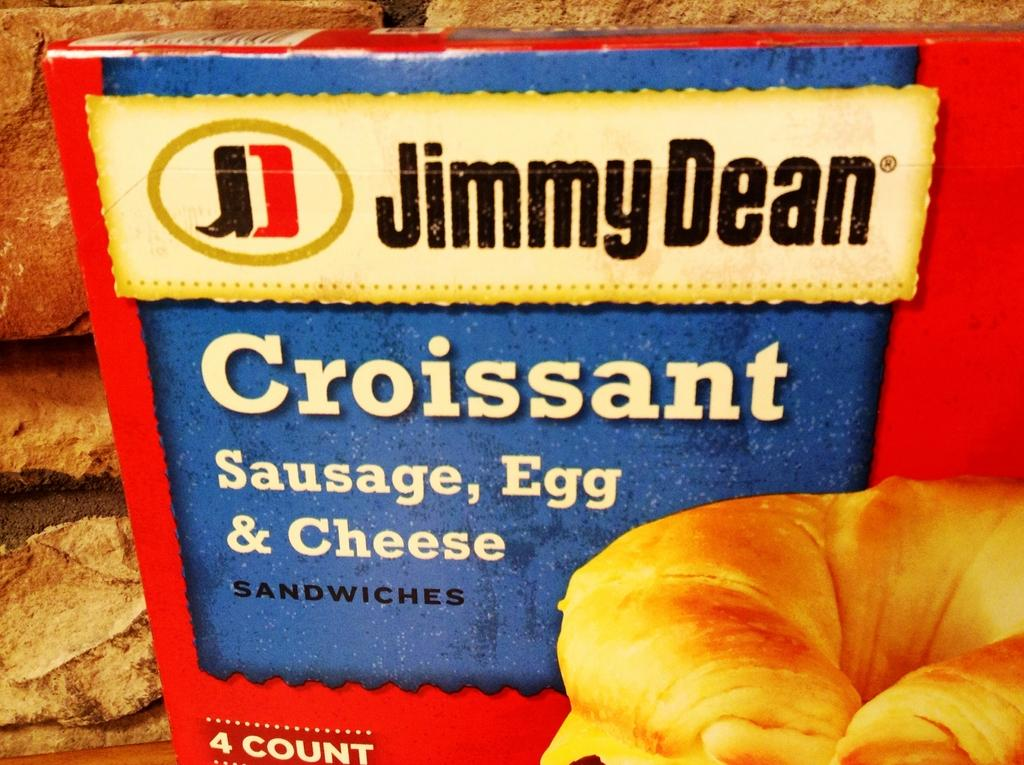What is located in the center of the image? There is a box and a snack item in the center of the image. What type of wall can be seen in the background of the image? There is a bricks wall in the background of the image. Where is the table located in the image? The table is in the bottom left corner of the image. What type of bell is hanging from the box in the image? There is no bell present in the image; it only features a box, a snack item, a bricks wall, and a table. 